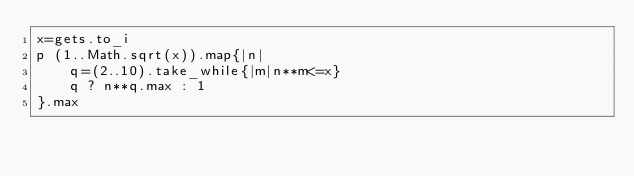<code> <loc_0><loc_0><loc_500><loc_500><_Ruby_>x=gets.to_i
p (1..Math.sqrt(x)).map{|n|
    q=(2..10).take_while{|m|n**m<=x}
    q ? n**q.max : 1
}.max
</code> 